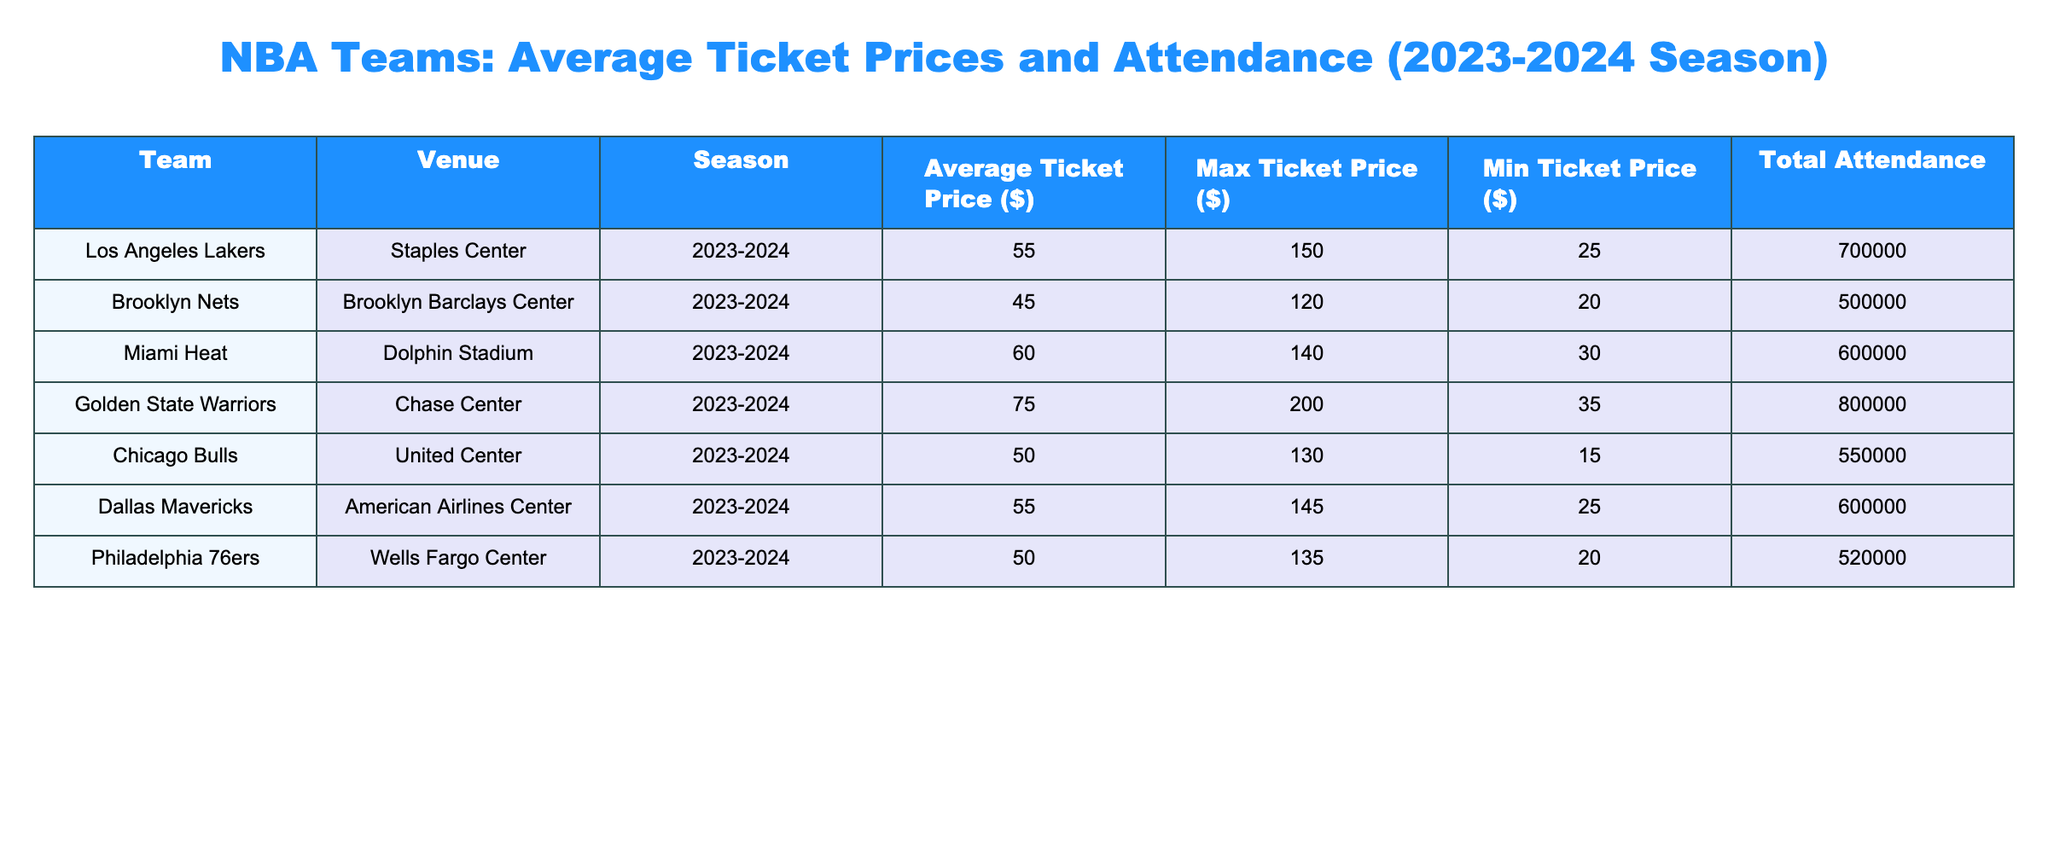What is the average ticket price for the Miami Heat? The average ticket price for the Miami Heat is listed directly in the table. It shows as 60 dollars.
Answer: 60 Which team has the highest minimum ticket price? By examining the "Min Ticket Price ($)" column in the table, the Golden State Warriors have the highest minimum ticket price listed at 35 dollars.
Answer: 35 What is the total attendance for the Brooklyn Nets? The total attendance for the Brooklyn Nets is 500,000 as noted in the "Total Attendance" column for that team.
Answer: 500000 Which team has the largest difference between its maximum and minimum ticket prices? To find this, calculate the difference for each team: 
- Lakers: 150 - 25 = 125
- Nets: 120 - 20 = 100
- Heat: 140 - 30 = 110
- Warriors: 200 - 35 = 165
- Bulls: 130 - 15 = 115
- Mavericks: 145 - 25 = 120
- 76ers: 135 - 20 = 115  
The Golden State Warriors have the largest difference of 165 dollars.
Answer: 165 Is the average ticket price for the Chicago Bulls greater than 50 dollars? Checking the average ticket price for the Chicago Bulls in the table, it is 50 dollars, which is not greater than 50. Hence the answer is no.
Answer: No What is the average ticket price for the NBA teams listed? To find the average ticket price, sum the average prices and divide by the number of teams: (55 + 45 + 60 + 75 + 50 + 55 + 50) = 390; there are 7 teams. Thus, the average is 390 / 7 ≈ 55.71 dollars.
Answer: 55.71 How many teams have an average ticket price above 50 dollars? From the table, the teams with average ticket prices above 50 dollars are the Miami Heat (60), Golden State Warriors (75), and the Dallas Mavericks (55). Counting these, there are 4 teams: Heat, Warriors, Mavericks, and Bulls.
Answer: 4 Which team has the highest average ticket price, and what is it? Checking the "Average Ticket Price ($)" column, the Golden State Warriors have the highest average ticket price listed at 75 dollars in their respective row.
Answer: 75 What is the total attendance of teams with average ticket prices below 50 dollars? The teams with average ticket prices below 50 dollars are the Brooklyn Nets (500,000) and the Chicago Bulls (550,000). Summing these gives 500,000 + 550,000 = 1,050,000 dollars.
Answer: 1050000 